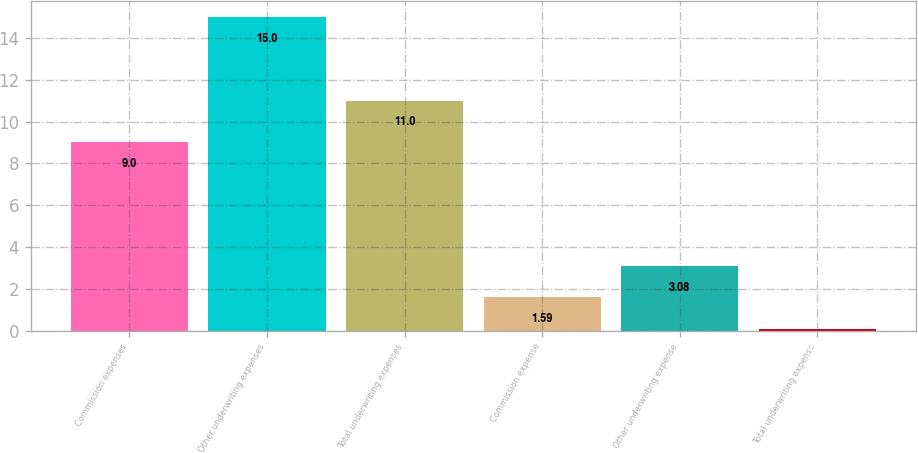<chart> <loc_0><loc_0><loc_500><loc_500><bar_chart><fcel>Commission expenses<fcel>Other underwriting expenses<fcel>Total underwriting expenses<fcel>Commission expense<fcel>Other underwriting expense<fcel>Total underwriting expense<nl><fcel>9<fcel>15<fcel>11<fcel>1.59<fcel>3.08<fcel>0.1<nl></chart> 